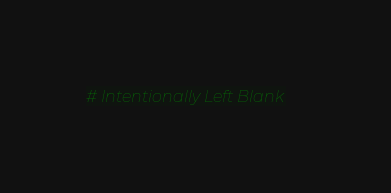Convert code to text. <code><loc_0><loc_0><loc_500><loc_500><_Python_># Intentionally Left Blank
</code> 